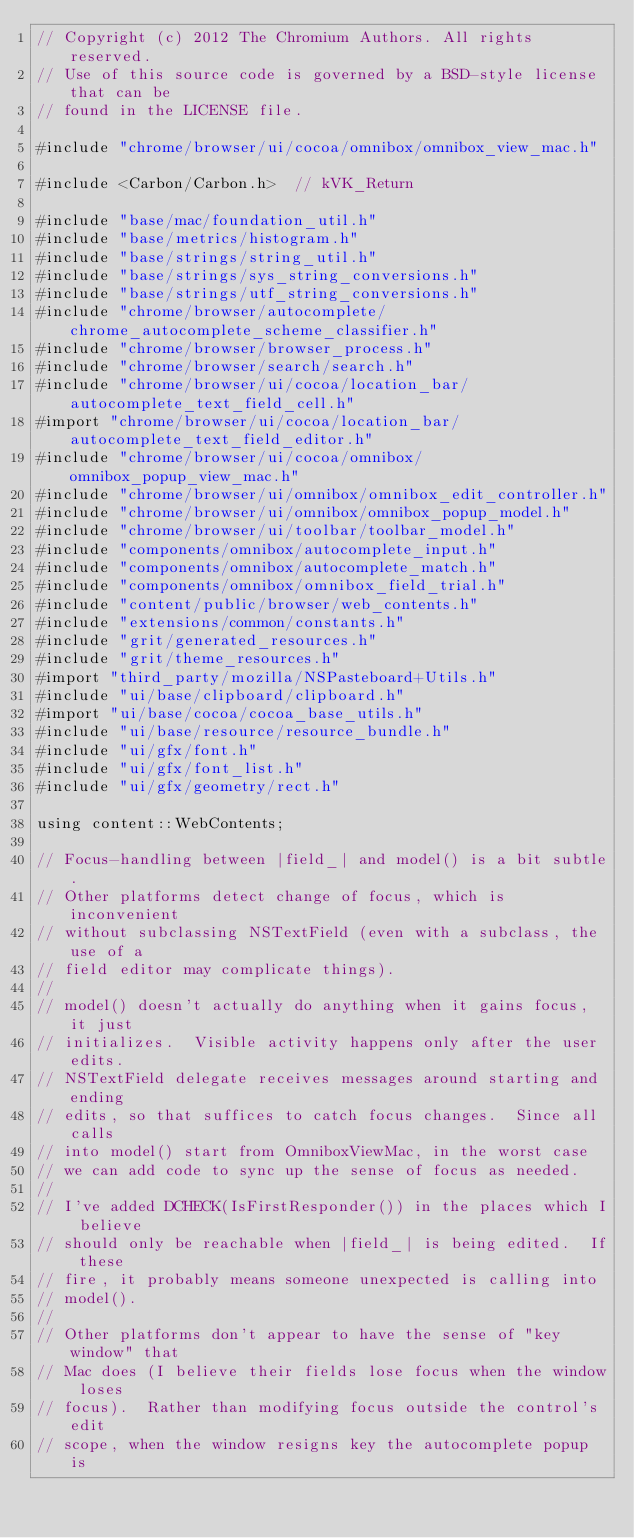Convert code to text. <code><loc_0><loc_0><loc_500><loc_500><_ObjectiveC_>// Copyright (c) 2012 The Chromium Authors. All rights reserved.
// Use of this source code is governed by a BSD-style license that can be
// found in the LICENSE file.

#include "chrome/browser/ui/cocoa/omnibox/omnibox_view_mac.h"

#include <Carbon/Carbon.h>  // kVK_Return

#include "base/mac/foundation_util.h"
#include "base/metrics/histogram.h"
#include "base/strings/string_util.h"
#include "base/strings/sys_string_conversions.h"
#include "base/strings/utf_string_conversions.h"
#include "chrome/browser/autocomplete/chrome_autocomplete_scheme_classifier.h"
#include "chrome/browser/browser_process.h"
#include "chrome/browser/search/search.h"
#include "chrome/browser/ui/cocoa/location_bar/autocomplete_text_field_cell.h"
#import "chrome/browser/ui/cocoa/location_bar/autocomplete_text_field_editor.h"
#include "chrome/browser/ui/cocoa/omnibox/omnibox_popup_view_mac.h"
#include "chrome/browser/ui/omnibox/omnibox_edit_controller.h"
#include "chrome/browser/ui/omnibox/omnibox_popup_model.h"
#include "chrome/browser/ui/toolbar/toolbar_model.h"
#include "components/omnibox/autocomplete_input.h"
#include "components/omnibox/autocomplete_match.h"
#include "components/omnibox/omnibox_field_trial.h"
#include "content/public/browser/web_contents.h"
#include "extensions/common/constants.h"
#include "grit/generated_resources.h"
#include "grit/theme_resources.h"
#import "third_party/mozilla/NSPasteboard+Utils.h"
#include "ui/base/clipboard/clipboard.h"
#import "ui/base/cocoa/cocoa_base_utils.h"
#include "ui/base/resource/resource_bundle.h"
#include "ui/gfx/font.h"
#include "ui/gfx/font_list.h"
#include "ui/gfx/geometry/rect.h"

using content::WebContents;

// Focus-handling between |field_| and model() is a bit subtle.
// Other platforms detect change of focus, which is inconvenient
// without subclassing NSTextField (even with a subclass, the use of a
// field editor may complicate things).
//
// model() doesn't actually do anything when it gains focus, it just
// initializes.  Visible activity happens only after the user edits.
// NSTextField delegate receives messages around starting and ending
// edits, so that suffices to catch focus changes.  Since all calls
// into model() start from OmniboxViewMac, in the worst case
// we can add code to sync up the sense of focus as needed.
//
// I've added DCHECK(IsFirstResponder()) in the places which I believe
// should only be reachable when |field_| is being edited.  If these
// fire, it probably means someone unexpected is calling into
// model().
//
// Other platforms don't appear to have the sense of "key window" that
// Mac does (I believe their fields lose focus when the window loses
// focus).  Rather than modifying focus outside the control's edit
// scope, when the window resigns key the autocomplete popup is</code> 